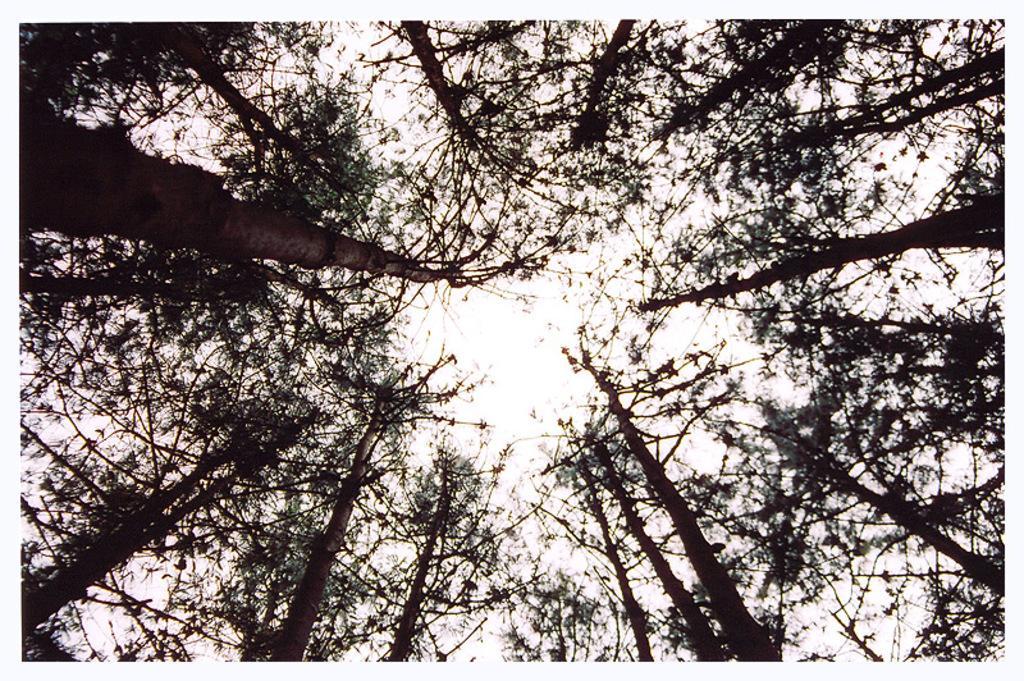Could you give a brief overview of what you see in this image? In this picture I can see trees, and in the background there is the sky. 